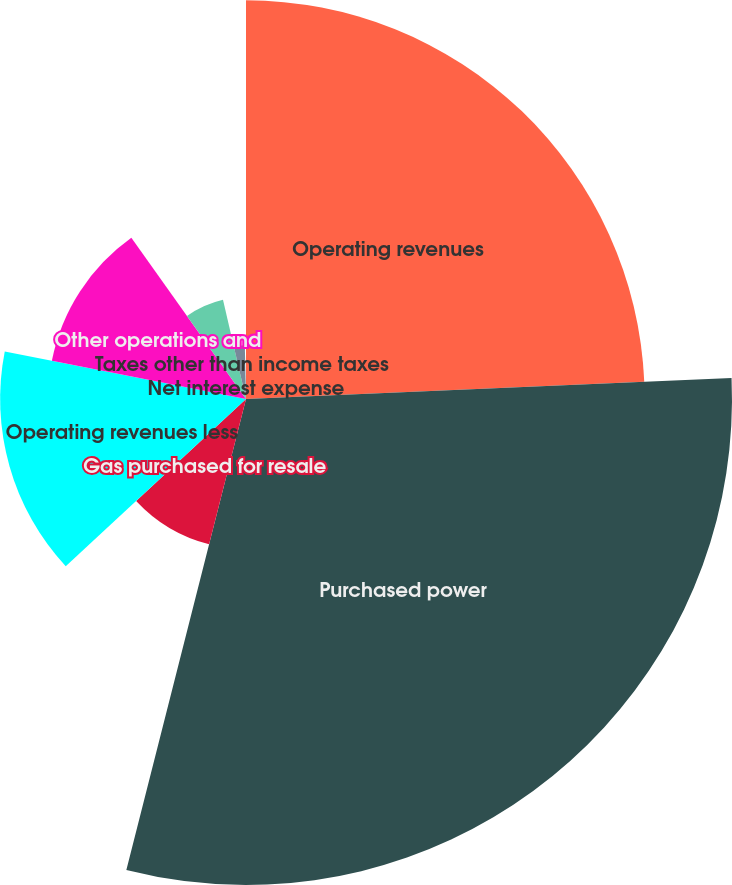Convert chart. <chart><loc_0><loc_0><loc_500><loc_500><pie_chart><fcel>Operating revenues<fcel>Purchased power<fcel>Gas purchased for resale<fcel>Operating revenues less<fcel>Other operations and<fcel>Depreciation and amortization<fcel>Taxes other than income taxes<fcel>Net interest expense<nl><fcel>24.32%<fcel>29.65%<fcel>9.14%<fcel>15.0%<fcel>12.07%<fcel>6.21%<fcel>3.28%<fcel>0.35%<nl></chart> 